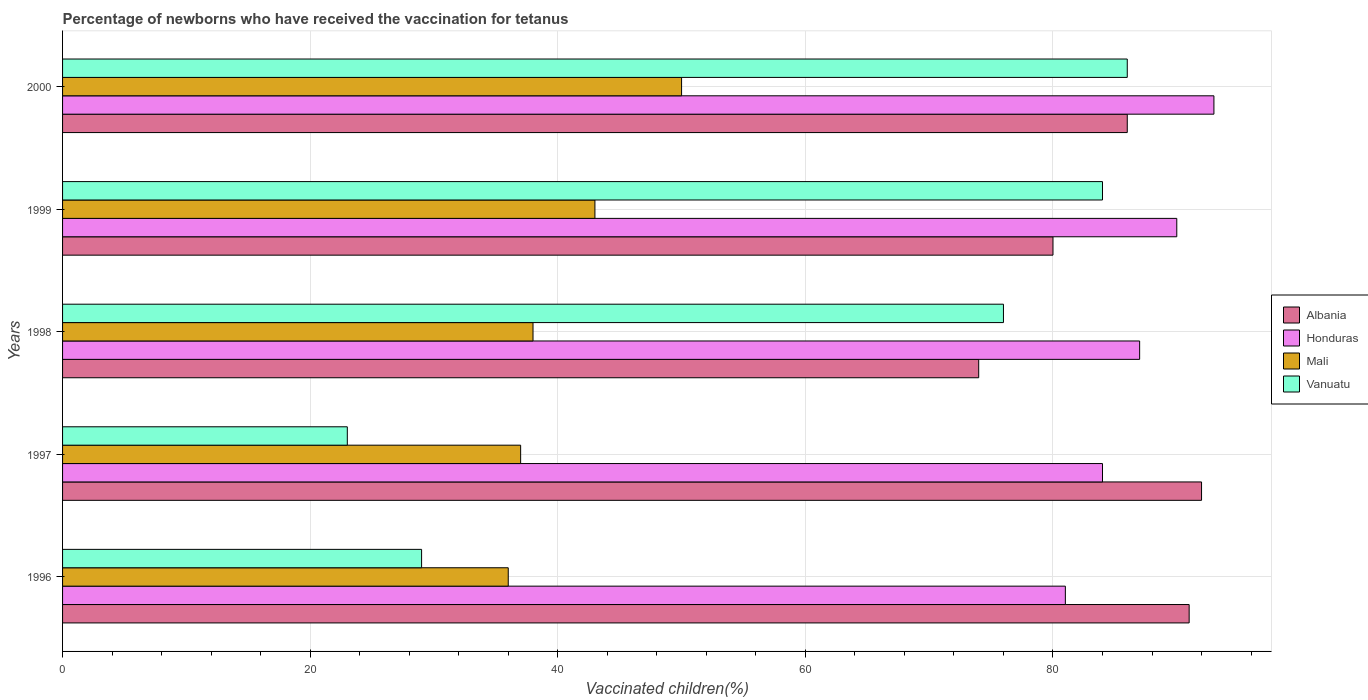How many groups of bars are there?
Ensure brevity in your answer.  5. Are the number of bars per tick equal to the number of legend labels?
Ensure brevity in your answer.  Yes. Are the number of bars on each tick of the Y-axis equal?
Your response must be concise. Yes. How many bars are there on the 4th tick from the top?
Your answer should be very brief. 4. How many bars are there on the 2nd tick from the bottom?
Make the answer very short. 4. In how many cases, is the number of bars for a given year not equal to the number of legend labels?
Offer a terse response. 0. Across all years, what is the maximum percentage of vaccinated children in Honduras?
Offer a very short reply. 93. In which year was the percentage of vaccinated children in Mali minimum?
Provide a short and direct response. 1996. What is the total percentage of vaccinated children in Honduras in the graph?
Your response must be concise. 435. What is the average percentage of vaccinated children in Vanuatu per year?
Your response must be concise. 59.6. In the year 1996, what is the difference between the percentage of vaccinated children in Vanuatu and percentage of vaccinated children in Honduras?
Your answer should be compact. -52. In how many years, is the percentage of vaccinated children in Mali greater than 12 %?
Provide a short and direct response. 5. What is the ratio of the percentage of vaccinated children in Albania in 1996 to that in 2000?
Provide a short and direct response. 1.06. Is the difference between the percentage of vaccinated children in Vanuatu in 1999 and 2000 greater than the difference between the percentage of vaccinated children in Honduras in 1999 and 2000?
Ensure brevity in your answer.  Yes. What is the difference between the highest and the second highest percentage of vaccinated children in Mali?
Offer a very short reply. 7. What is the difference between the highest and the lowest percentage of vaccinated children in Vanuatu?
Provide a succinct answer. 63. Is the sum of the percentage of vaccinated children in Mali in 1998 and 1999 greater than the maximum percentage of vaccinated children in Albania across all years?
Your answer should be compact. No. What does the 2nd bar from the top in 1998 represents?
Provide a short and direct response. Mali. What does the 4th bar from the bottom in 1996 represents?
Your response must be concise. Vanuatu. Are all the bars in the graph horizontal?
Make the answer very short. Yes. What is the difference between two consecutive major ticks on the X-axis?
Keep it short and to the point. 20. Does the graph contain any zero values?
Your answer should be very brief. No. What is the title of the graph?
Your answer should be very brief. Percentage of newborns who have received the vaccination for tetanus. What is the label or title of the X-axis?
Your response must be concise. Vaccinated children(%). What is the label or title of the Y-axis?
Ensure brevity in your answer.  Years. What is the Vaccinated children(%) of Albania in 1996?
Your answer should be very brief. 91. What is the Vaccinated children(%) of Vanuatu in 1996?
Provide a short and direct response. 29. What is the Vaccinated children(%) of Albania in 1997?
Offer a terse response. 92. What is the Vaccinated children(%) of Vanuatu in 1997?
Your response must be concise. 23. What is the Vaccinated children(%) in Albania in 1998?
Offer a terse response. 74. What is the Vaccinated children(%) of Honduras in 1998?
Offer a very short reply. 87. What is the Vaccinated children(%) in Mali in 1999?
Your answer should be compact. 43. What is the Vaccinated children(%) of Vanuatu in 1999?
Offer a very short reply. 84. What is the Vaccinated children(%) of Albania in 2000?
Offer a very short reply. 86. What is the Vaccinated children(%) in Honduras in 2000?
Make the answer very short. 93. What is the Vaccinated children(%) of Mali in 2000?
Provide a succinct answer. 50. Across all years, what is the maximum Vaccinated children(%) in Albania?
Provide a succinct answer. 92. Across all years, what is the maximum Vaccinated children(%) in Honduras?
Ensure brevity in your answer.  93. Across all years, what is the minimum Vaccinated children(%) of Honduras?
Ensure brevity in your answer.  81. Across all years, what is the minimum Vaccinated children(%) of Mali?
Your response must be concise. 36. What is the total Vaccinated children(%) of Albania in the graph?
Provide a short and direct response. 423. What is the total Vaccinated children(%) in Honduras in the graph?
Give a very brief answer. 435. What is the total Vaccinated children(%) of Mali in the graph?
Offer a very short reply. 204. What is the total Vaccinated children(%) of Vanuatu in the graph?
Your response must be concise. 298. What is the difference between the Vaccinated children(%) in Albania in 1996 and that in 1997?
Ensure brevity in your answer.  -1. What is the difference between the Vaccinated children(%) in Mali in 1996 and that in 1997?
Your response must be concise. -1. What is the difference between the Vaccinated children(%) of Vanuatu in 1996 and that in 1997?
Your answer should be very brief. 6. What is the difference between the Vaccinated children(%) in Honduras in 1996 and that in 1998?
Make the answer very short. -6. What is the difference between the Vaccinated children(%) in Mali in 1996 and that in 1998?
Your answer should be compact. -2. What is the difference between the Vaccinated children(%) in Vanuatu in 1996 and that in 1998?
Your response must be concise. -47. What is the difference between the Vaccinated children(%) in Albania in 1996 and that in 1999?
Provide a succinct answer. 11. What is the difference between the Vaccinated children(%) of Vanuatu in 1996 and that in 1999?
Make the answer very short. -55. What is the difference between the Vaccinated children(%) in Vanuatu in 1996 and that in 2000?
Provide a short and direct response. -57. What is the difference between the Vaccinated children(%) of Albania in 1997 and that in 1998?
Offer a very short reply. 18. What is the difference between the Vaccinated children(%) of Mali in 1997 and that in 1998?
Give a very brief answer. -1. What is the difference between the Vaccinated children(%) in Vanuatu in 1997 and that in 1998?
Your answer should be very brief. -53. What is the difference between the Vaccinated children(%) in Mali in 1997 and that in 1999?
Give a very brief answer. -6. What is the difference between the Vaccinated children(%) of Vanuatu in 1997 and that in 1999?
Provide a short and direct response. -61. What is the difference between the Vaccinated children(%) of Albania in 1997 and that in 2000?
Your response must be concise. 6. What is the difference between the Vaccinated children(%) in Honduras in 1997 and that in 2000?
Give a very brief answer. -9. What is the difference between the Vaccinated children(%) of Mali in 1997 and that in 2000?
Your response must be concise. -13. What is the difference between the Vaccinated children(%) in Vanuatu in 1997 and that in 2000?
Provide a succinct answer. -63. What is the difference between the Vaccinated children(%) of Honduras in 1998 and that in 1999?
Make the answer very short. -3. What is the difference between the Vaccinated children(%) in Mali in 1998 and that in 1999?
Provide a succinct answer. -5. What is the difference between the Vaccinated children(%) in Albania in 1998 and that in 2000?
Your response must be concise. -12. What is the difference between the Vaccinated children(%) in Honduras in 1998 and that in 2000?
Provide a short and direct response. -6. What is the difference between the Vaccinated children(%) of Mali in 1998 and that in 2000?
Your response must be concise. -12. What is the difference between the Vaccinated children(%) of Vanuatu in 1998 and that in 2000?
Make the answer very short. -10. What is the difference between the Vaccinated children(%) of Honduras in 1999 and that in 2000?
Provide a succinct answer. -3. What is the difference between the Vaccinated children(%) in Mali in 1999 and that in 2000?
Your response must be concise. -7. What is the difference between the Vaccinated children(%) of Albania in 1996 and the Vaccinated children(%) of Mali in 1997?
Give a very brief answer. 54. What is the difference between the Vaccinated children(%) of Albania in 1996 and the Vaccinated children(%) of Vanuatu in 1997?
Provide a short and direct response. 68. What is the difference between the Vaccinated children(%) of Honduras in 1996 and the Vaccinated children(%) of Mali in 1997?
Your response must be concise. 44. What is the difference between the Vaccinated children(%) of Honduras in 1996 and the Vaccinated children(%) of Vanuatu in 1997?
Provide a succinct answer. 58. What is the difference between the Vaccinated children(%) in Albania in 1996 and the Vaccinated children(%) in Mali in 1998?
Offer a terse response. 53. What is the difference between the Vaccinated children(%) in Albania in 1996 and the Vaccinated children(%) in Vanuatu in 1998?
Provide a succinct answer. 15. What is the difference between the Vaccinated children(%) of Honduras in 1996 and the Vaccinated children(%) of Mali in 1998?
Provide a succinct answer. 43. What is the difference between the Vaccinated children(%) of Mali in 1996 and the Vaccinated children(%) of Vanuatu in 1998?
Your answer should be very brief. -40. What is the difference between the Vaccinated children(%) of Honduras in 1996 and the Vaccinated children(%) of Mali in 1999?
Provide a short and direct response. 38. What is the difference between the Vaccinated children(%) of Mali in 1996 and the Vaccinated children(%) of Vanuatu in 1999?
Provide a short and direct response. -48. What is the difference between the Vaccinated children(%) of Albania in 1996 and the Vaccinated children(%) of Mali in 2000?
Offer a very short reply. 41. What is the difference between the Vaccinated children(%) of Honduras in 1996 and the Vaccinated children(%) of Mali in 2000?
Make the answer very short. 31. What is the difference between the Vaccinated children(%) of Albania in 1997 and the Vaccinated children(%) of Vanuatu in 1998?
Offer a terse response. 16. What is the difference between the Vaccinated children(%) of Mali in 1997 and the Vaccinated children(%) of Vanuatu in 1998?
Give a very brief answer. -39. What is the difference between the Vaccinated children(%) of Albania in 1997 and the Vaccinated children(%) of Honduras in 1999?
Ensure brevity in your answer.  2. What is the difference between the Vaccinated children(%) in Albania in 1997 and the Vaccinated children(%) in Vanuatu in 1999?
Provide a succinct answer. 8. What is the difference between the Vaccinated children(%) in Honduras in 1997 and the Vaccinated children(%) in Mali in 1999?
Ensure brevity in your answer.  41. What is the difference between the Vaccinated children(%) in Honduras in 1997 and the Vaccinated children(%) in Vanuatu in 1999?
Offer a terse response. 0. What is the difference between the Vaccinated children(%) of Mali in 1997 and the Vaccinated children(%) of Vanuatu in 1999?
Offer a very short reply. -47. What is the difference between the Vaccinated children(%) of Albania in 1997 and the Vaccinated children(%) of Vanuatu in 2000?
Your response must be concise. 6. What is the difference between the Vaccinated children(%) of Honduras in 1997 and the Vaccinated children(%) of Vanuatu in 2000?
Keep it short and to the point. -2. What is the difference between the Vaccinated children(%) of Mali in 1997 and the Vaccinated children(%) of Vanuatu in 2000?
Offer a very short reply. -49. What is the difference between the Vaccinated children(%) in Albania in 1998 and the Vaccinated children(%) in Honduras in 1999?
Make the answer very short. -16. What is the difference between the Vaccinated children(%) of Honduras in 1998 and the Vaccinated children(%) of Mali in 1999?
Provide a succinct answer. 44. What is the difference between the Vaccinated children(%) in Honduras in 1998 and the Vaccinated children(%) in Vanuatu in 1999?
Provide a succinct answer. 3. What is the difference between the Vaccinated children(%) of Mali in 1998 and the Vaccinated children(%) of Vanuatu in 1999?
Your answer should be compact. -46. What is the difference between the Vaccinated children(%) of Albania in 1998 and the Vaccinated children(%) of Honduras in 2000?
Your answer should be compact. -19. What is the difference between the Vaccinated children(%) of Albania in 1998 and the Vaccinated children(%) of Mali in 2000?
Give a very brief answer. 24. What is the difference between the Vaccinated children(%) of Albania in 1998 and the Vaccinated children(%) of Vanuatu in 2000?
Ensure brevity in your answer.  -12. What is the difference between the Vaccinated children(%) of Honduras in 1998 and the Vaccinated children(%) of Mali in 2000?
Give a very brief answer. 37. What is the difference between the Vaccinated children(%) in Mali in 1998 and the Vaccinated children(%) in Vanuatu in 2000?
Your response must be concise. -48. What is the difference between the Vaccinated children(%) of Mali in 1999 and the Vaccinated children(%) of Vanuatu in 2000?
Offer a terse response. -43. What is the average Vaccinated children(%) of Albania per year?
Provide a succinct answer. 84.6. What is the average Vaccinated children(%) of Mali per year?
Your answer should be very brief. 40.8. What is the average Vaccinated children(%) of Vanuatu per year?
Offer a terse response. 59.6. In the year 1996, what is the difference between the Vaccinated children(%) of Albania and Vaccinated children(%) of Vanuatu?
Offer a terse response. 62. In the year 1996, what is the difference between the Vaccinated children(%) of Honduras and Vaccinated children(%) of Mali?
Your answer should be very brief. 45. In the year 1996, what is the difference between the Vaccinated children(%) in Mali and Vaccinated children(%) in Vanuatu?
Give a very brief answer. 7. In the year 1997, what is the difference between the Vaccinated children(%) in Honduras and Vaccinated children(%) in Mali?
Your answer should be very brief. 47. In the year 1998, what is the difference between the Vaccinated children(%) in Honduras and Vaccinated children(%) in Vanuatu?
Keep it short and to the point. 11. In the year 1998, what is the difference between the Vaccinated children(%) in Mali and Vaccinated children(%) in Vanuatu?
Provide a short and direct response. -38. In the year 1999, what is the difference between the Vaccinated children(%) in Albania and Vaccinated children(%) in Mali?
Keep it short and to the point. 37. In the year 1999, what is the difference between the Vaccinated children(%) in Albania and Vaccinated children(%) in Vanuatu?
Your answer should be compact. -4. In the year 1999, what is the difference between the Vaccinated children(%) in Honduras and Vaccinated children(%) in Vanuatu?
Provide a succinct answer. 6. In the year 1999, what is the difference between the Vaccinated children(%) of Mali and Vaccinated children(%) of Vanuatu?
Offer a terse response. -41. In the year 2000, what is the difference between the Vaccinated children(%) in Albania and Vaccinated children(%) in Honduras?
Your answer should be compact. -7. In the year 2000, what is the difference between the Vaccinated children(%) of Albania and Vaccinated children(%) of Mali?
Offer a very short reply. 36. In the year 2000, what is the difference between the Vaccinated children(%) in Honduras and Vaccinated children(%) in Mali?
Offer a terse response. 43. In the year 2000, what is the difference between the Vaccinated children(%) in Mali and Vaccinated children(%) in Vanuatu?
Make the answer very short. -36. What is the ratio of the Vaccinated children(%) in Mali in 1996 to that in 1997?
Your response must be concise. 0.97. What is the ratio of the Vaccinated children(%) of Vanuatu in 1996 to that in 1997?
Ensure brevity in your answer.  1.26. What is the ratio of the Vaccinated children(%) of Albania in 1996 to that in 1998?
Keep it short and to the point. 1.23. What is the ratio of the Vaccinated children(%) in Vanuatu in 1996 to that in 1998?
Your answer should be compact. 0.38. What is the ratio of the Vaccinated children(%) of Albania in 1996 to that in 1999?
Give a very brief answer. 1.14. What is the ratio of the Vaccinated children(%) of Honduras in 1996 to that in 1999?
Ensure brevity in your answer.  0.9. What is the ratio of the Vaccinated children(%) of Mali in 1996 to that in 1999?
Keep it short and to the point. 0.84. What is the ratio of the Vaccinated children(%) in Vanuatu in 1996 to that in 1999?
Keep it short and to the point. 0.35. What is the ratio of the Vaccinated children(%) in Albania in 1996 to that in 2000?
Keep it short and to the point. 1.06. What is the ratio of the Vaccinated children(%) in Honduras in 1996 to that in 2000?
Provide a succinct answer. 0.87. What is the ratio of the Vaccinated children(%) in Mali in 1996 to that in 2000?
Your answer should be compact. 0.72. What is the ratio of the Vaccinated children(%) in Vanuatu in 1996 to that in 2000?
Your answer should be very brief. 0.34. What is the ratio of the Vaccinated children(%) in Albania in 1997 to that in 1998?
Provide a succinct answer. 1.24. What is the ratio of the Vaccinated children(%) of Honduras in 1997 to that in 1998?
Your answer should be compact. 0.97. What is the ratio of the Vaccinated children(%) of Mali in 1997 to that in 1998?
Keep it short and to the point. 0.97. What is the ratio of the Vaccinated children(%) in Vanuatu in 1997 to that in 1998?
Provide a succinct answer. 0.3. What is the ratio of the Vaccinated children(%) in Albania in 1997 to that in 1999?
Make the answer very short. 1.15. What is the ratio of the Vaccinated children(%) of Mali in 1997 to that in 1999?
Ensure brevity in your answer.  0.86. What is the ratio of the Vaccinated children(%) in Vanuatu in 1997 to that in 1999?
Make the answer very short. 0.27. What is the ratio of the Vaccinated children(%) in Albania in 1997 to that in 2000?
Make the answer very short. 1.07. What is the ratio of the Vaccinated children(%) of Honduras in 1997 to that in 2000?
Provide a succinct answer. 0.9. What is the ratio of the Vaccinated children(%) of Mali in 1997 to that in 2000?
Provide a short and direct response. 0.74. What is the ratio of the Vaccinated children(%) of Vanuatu in 1997 to that in 2000?
Keep it short and to the point. 0.27. What is the ratio of the Vaccinated children(%) of Albania in 1998 to that in 1999?
Your response must be concise. 0.93. What is the ratio of the Vaccinated children(%) in Honduras in 1998 to that in 1999?
Ensure brevity in your answer.  0.97. What is the ratio of the Vaccinated children(%) in Mali in 1998 to that in 1999?
Offer a very short reply. 0.88. What is the ratio of the Vaccinated children(%) of Vanuatu in 1998 to that in 1999?
Offer a very short reply. 0.9. What is the ratio of the Vaccinated children(%) of Albania in 1998 to that in 2000?
Your response must be concise. 0.86. What is the ratio of the Vaccinated children(%) in Honduras in 1998 to that in 2000?
Your answer should be compact. 0.94. What is the ratio of the Vaccinated children(%) in Mali in 1998 to that in 2000?
Ensure brevity in your answer.  0.76. What is the ratio of the Vaccinated children(%) of Vanuatu in 1998 to that in 2000?
Provide a succinct answer. 0.88. What is the ratio of the Vaccinated children(%) in Albania in 1999 to that in 2000?
Your response must be concise. 0.93. What is the ratio of the Vaccinated children(%) in Mali in 1999 to that in 2000?
Provide a succinct answer. 0.86. What is the ratio of the Vaccinated children(%) in Vanuatu in 1999 to that in 2000?
Provide a succinct answer. 0.98. What is the difference between the highest and the second highest Vaccinated children(%) in Honduras?
Ensure brevity in your answer.  3. What is the difference between the highest and the second highest Vaccinated children(%) in Mali?
Offer a terse response. 7. What is the difference between the highest and the second highest Vaccinated children(%) in Vanuatu?
Your answer should be very brief. 2. What is the difference between the highest and the lowest Vaccinated children(%) in Honduras?
Provide a short and direct response. 12. 